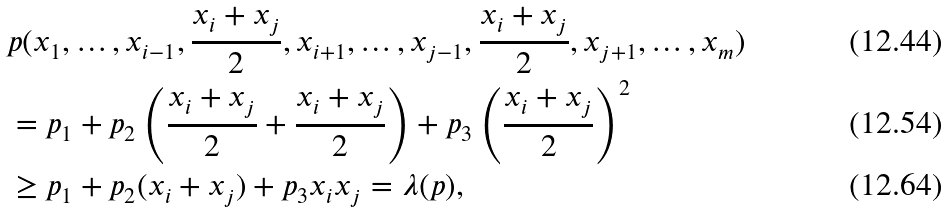<formula> <loc_0><loc_0><loc_500><loc_500>& p ( x _ { 1 } , \dots , x _ { i - 1 } , \frac { x _ { i } + x _ { j } } { 2 } , x _ { i + 1 } , \dots , x _ { j - 1 } , \frac { x _ { i } + x _ { j } } { 2 } , x _ { j + 1 } , \dots , x _ { m } ) \\ & = p _ { 1 } + p _ { 2 } \left ( \frac { x _ { i } + x _ { j } } { 2 } + \frac { x _ { i } + x _ { j } } { 2 } \right ) + p _ { 3 } \left ( \frac { x _ { i } + x _ { j } } { 2 } \right ) ^ { 2 } \\ & \geq p _ { 1 } + p _ { 2 } ( x _ { i } + x _ { j } ) + p _ { 3 } x _ { i } x _ { j } = \lambda ( p ) ,</formula> 